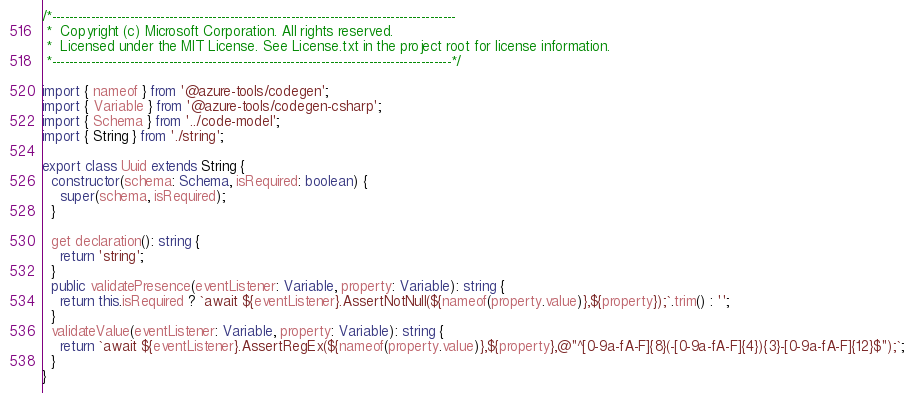Convert code to text. <code><loc_0><loc_0><loc_500><loc_500><_TypeScript_>/*---------------------------------------------------------------------------------------------
 *  Copyright (c) Microsoft Corporation. All rights reserved.
 *  Licensed under the MIT License. See License.txt in the project root for license information.
 *--------------------------------------------------------------------------------------------*/

import { nameof } from '@azure-tools/codegen';
import { Variable } from '@azure-tools/codegen-csharp';
import { Schema } from '../code-model';
import { String } from './string';

export class Uuid extends String {
  constructor(schema: Schema, isRequired: boolean) {
    super(schema, isRequired);
  }

  get declaration(): string {
    return 'string';
  }
  public validatePresence(eventListener: Variable, property: Variable): string {
    return this.isRequired ? `await ${eventListener}.AssertNotNull(${nameof(property.value)},${property});`.trim() : '';
  }
  validateValue(eventListener: Variable, property: Variable): string {
    return `await ${eventListener}.AssertRegEx(${nameof(property.value)},${property},@"^[0-9a-fA-F]{8}(-[0-9a-fA-F]{4}){3}-[0-9a-fA-F]{12}$");`;
  }
}
</code> 